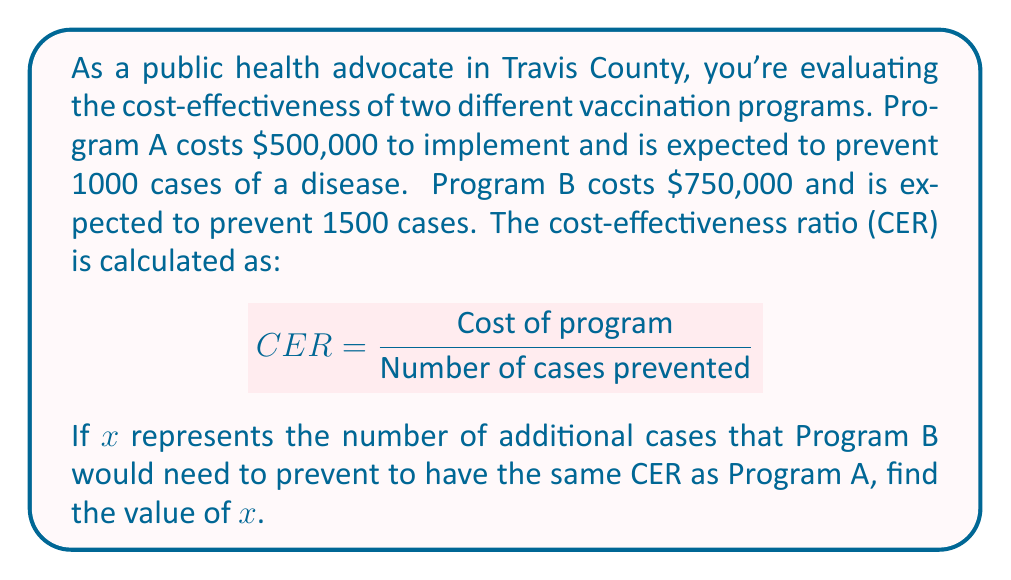Could you help me with this problem? Let's approach this step-by-step:

1) First, let's calculate the CER for Program A:
   $$ CER_A = \frac{500,000}{1000} = 500 $$

2) Now, we want Program B to have the same CER. We can set up an equation:
   $$ \frac{750,000}{1500 + x} = 500 $$

3) Let's solve this equation for $x$:
   $$ 750,000 = 500(1500 + x) $$
   $$ 750,000 = 750,000 + 500x $$

4) Subtract 750,000 from both sides:
   $$ 0 = 500x $$

5) Divide both sides by 500:
   $$ x = 0 $$

6) Therefore, Program B doesn't need to prevent any additional cases to have the same CER as Program A.

7) We can verify this:
   $$ CER_B = \frac{750,000}{1500} = 500 $$

   This is indeed equal to $CER_A$.
Answer: $x = 0$ 